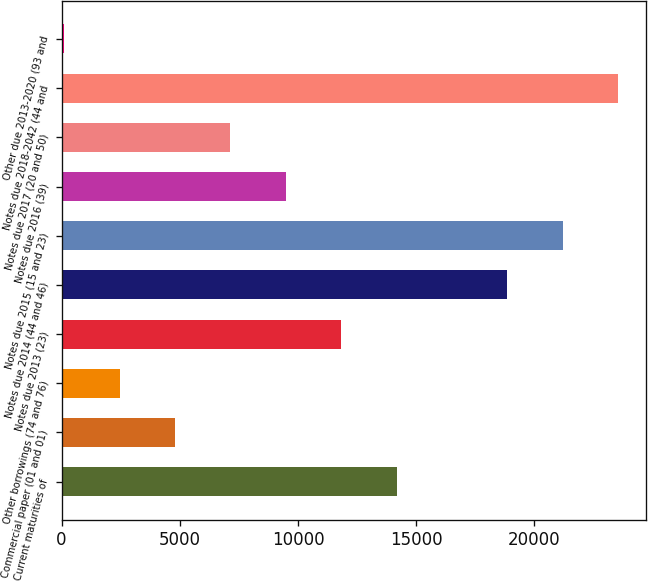<chart> <loc_0><loc_0><loc_500><loc_500><bar_chart><fcel>Current maturities of<fcel>Commercial paper (01 and 01)<fcel>Other borrowings (74 and 76)<fcel>Notes due 2013 (23)<fcel>Notes due 2014 (44 and 46)<fcel>Notes due 2015 (15 and 23)<fcel>Notes due 2016 (39)<fcel>Notes due 2017 (20 and 50)<fcel>Notes due 2018-2042 (44 and<fcel>Other due 2013-2020 (93 and<nl><fcel>14169.6<fcel>4795.2<fcel>2451.6<fcel>11826<fcel>18856.8<fcel>21200.4<fcel>9482.4<fcel>7138.8<fcel>23544<fcel>108<nl></chart> 